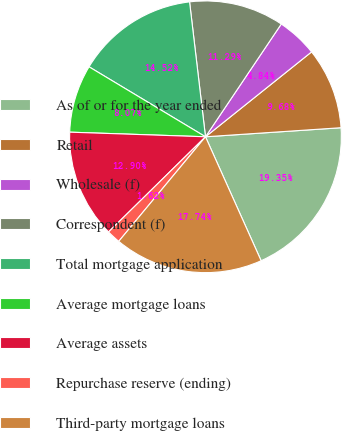Convert chart to OTSL. <chart><loc_0><loc_0><loc_500><loc_500><pie_chart><fcel>As of or for the year ended<fcel>Retail<fcel>Wholesale (f)<fcel>Correspondent (f)<fcel>Total mortgage application<fcel>Average mortgage loans<fcel>Average assets<fcel>Repurchase reserve (ending)<fcel>Third-party mortgage loans<nl><fcel>19.35%<fcel>9.68%<fcel>4.84%<fcel>11.29%<fcel>14.52%<fcel>8.07%<fcel>12.9%<fcel>1.62%<fcel>17.74%<nl></chart> 